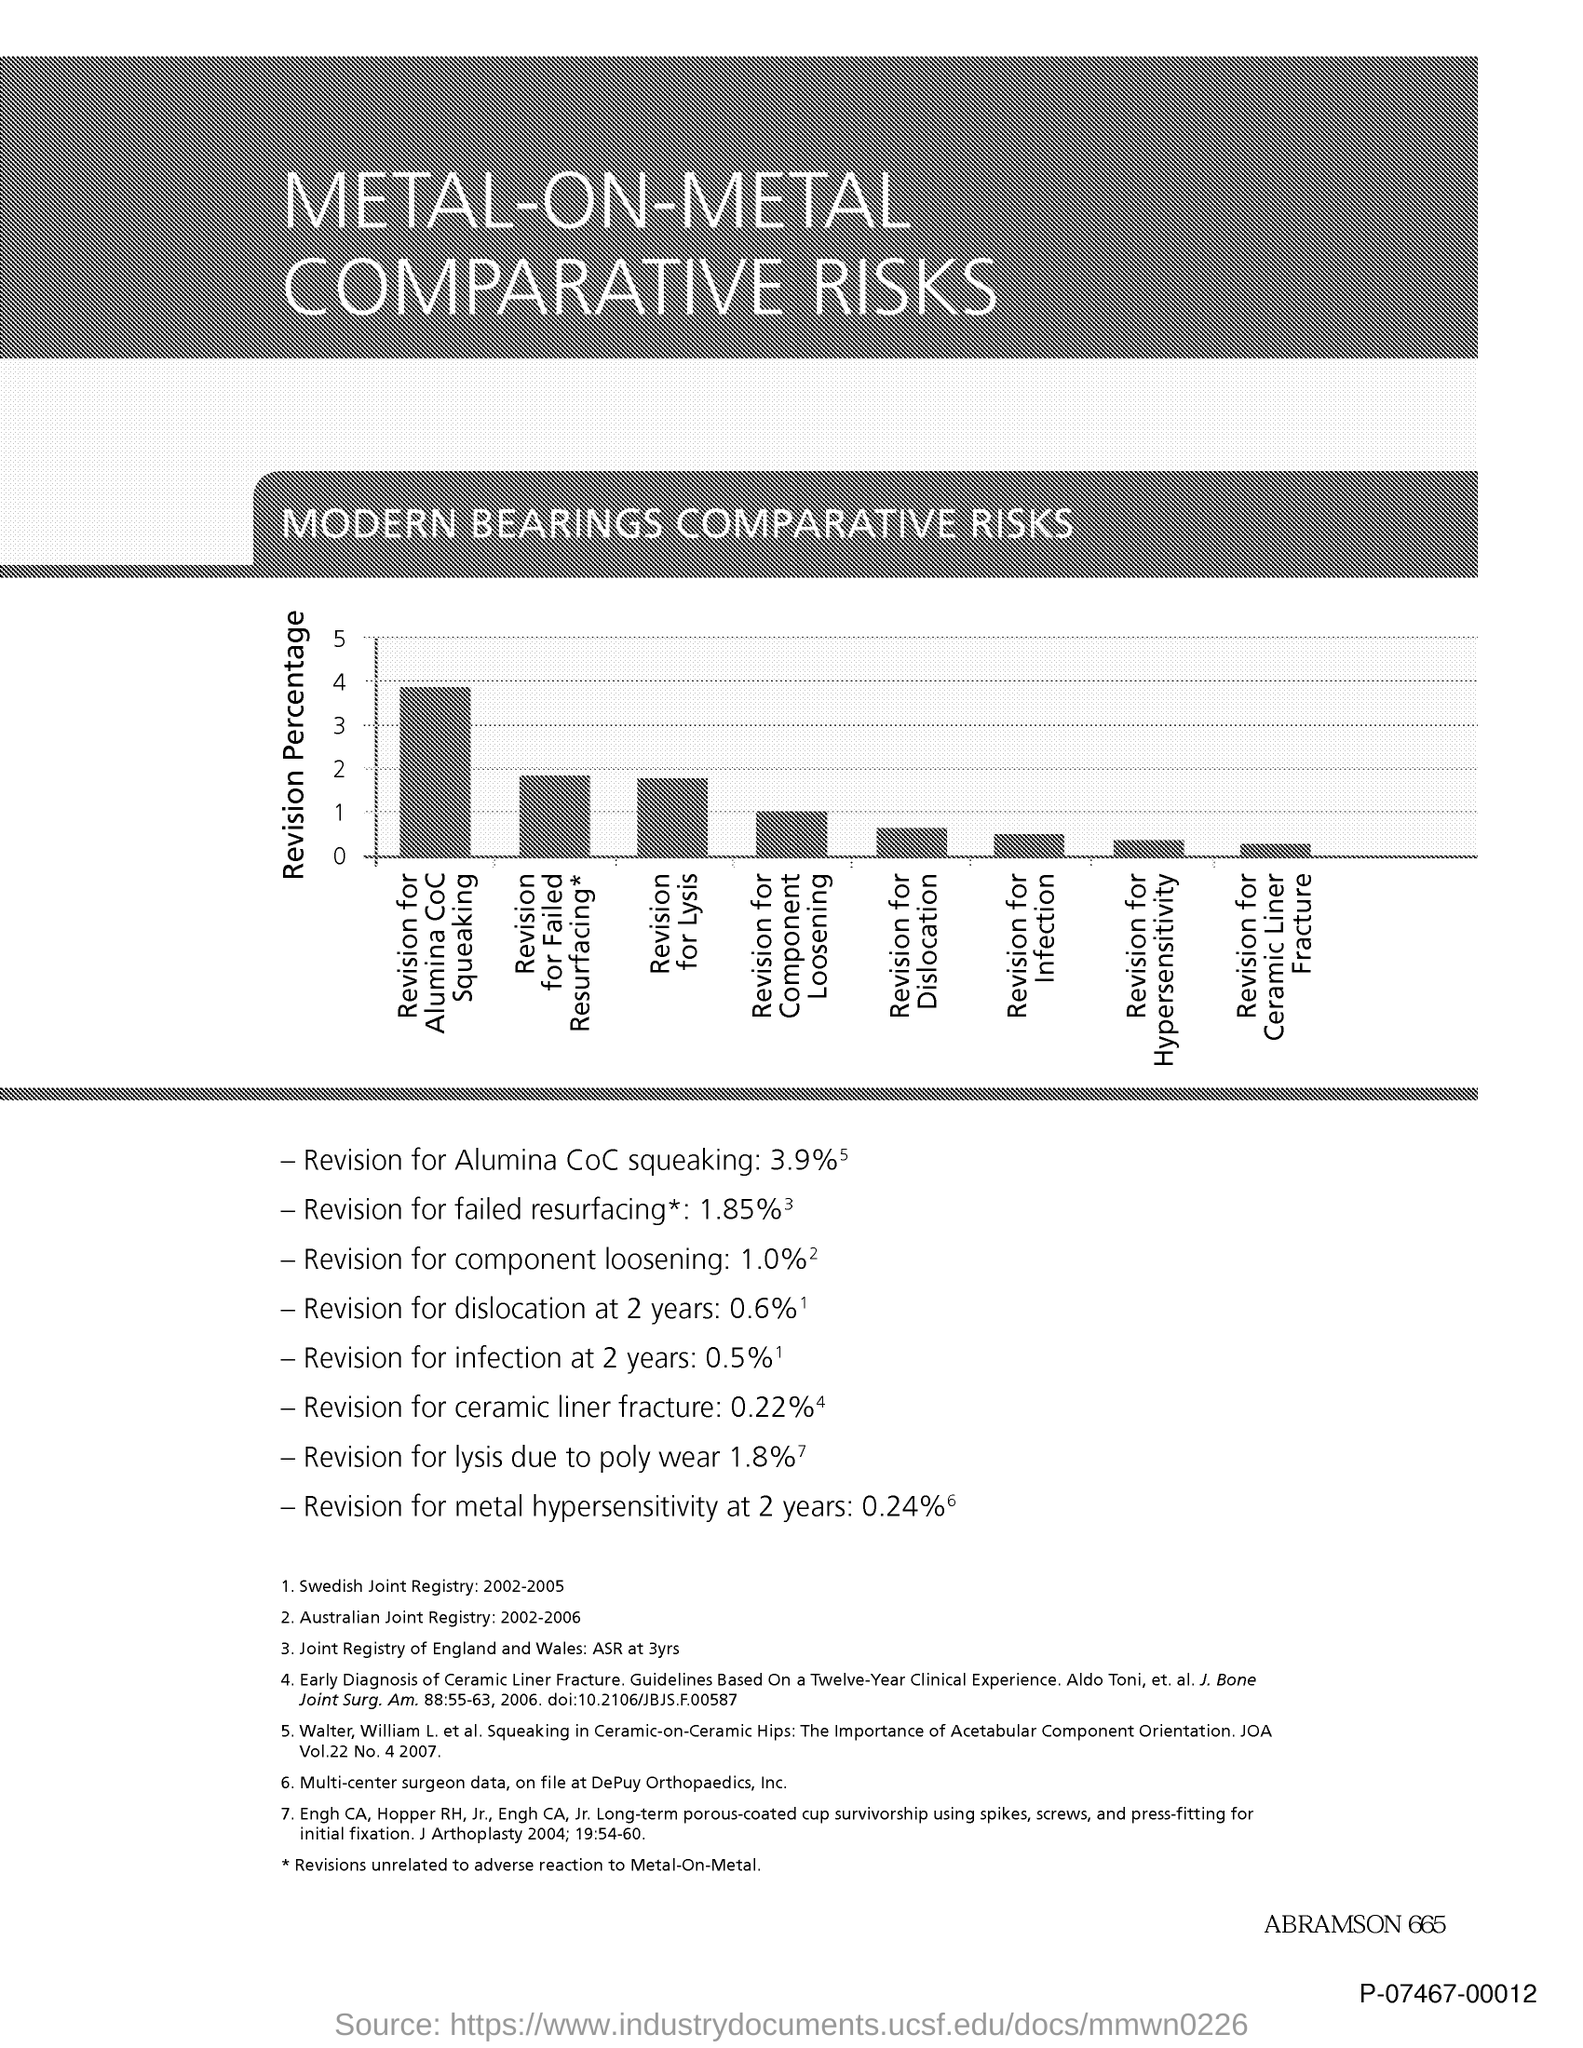Mention a couple of crucial points in this snapshot. The title of the document is "Metal-on-Metal Comparative Risks". The y-axis represents the percentage of revision in the given data. 